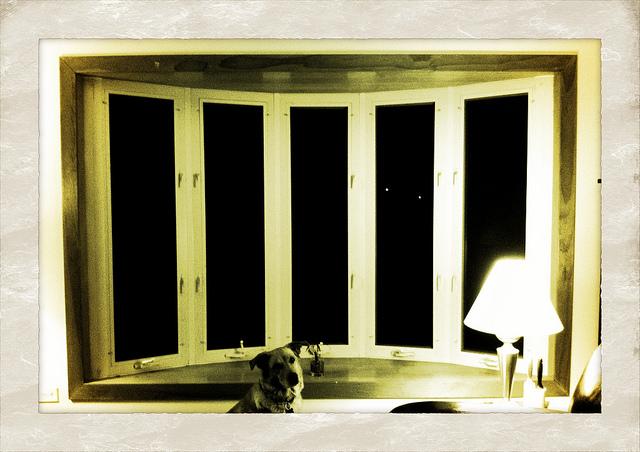Is this dog most likely to be a purebred or a mutt?
Short answer required. Mutt. Is this dog in the pound?
Give a very brief answer. No. Was the person taking this picture tall?
Concise answer only. Yes. 